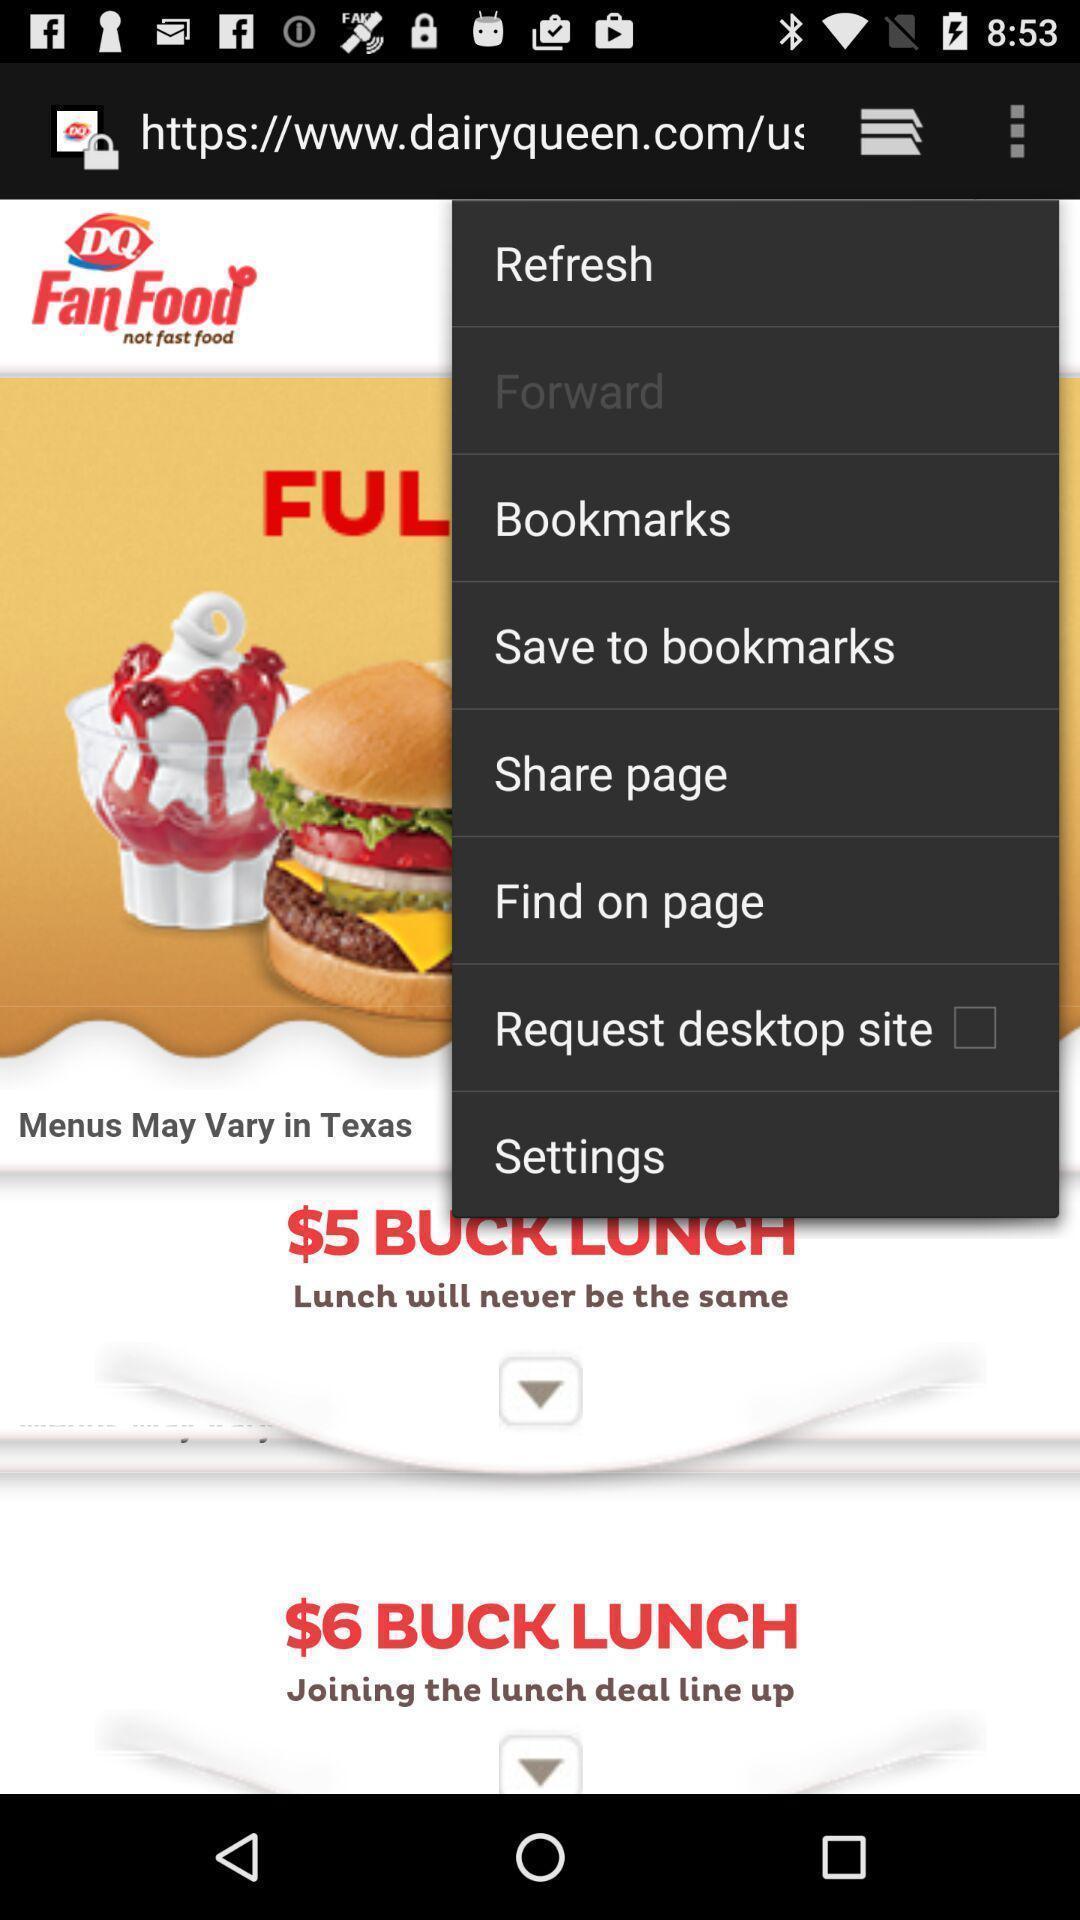Describe the visual elements of this screenshot. Screen shows features of web page. 